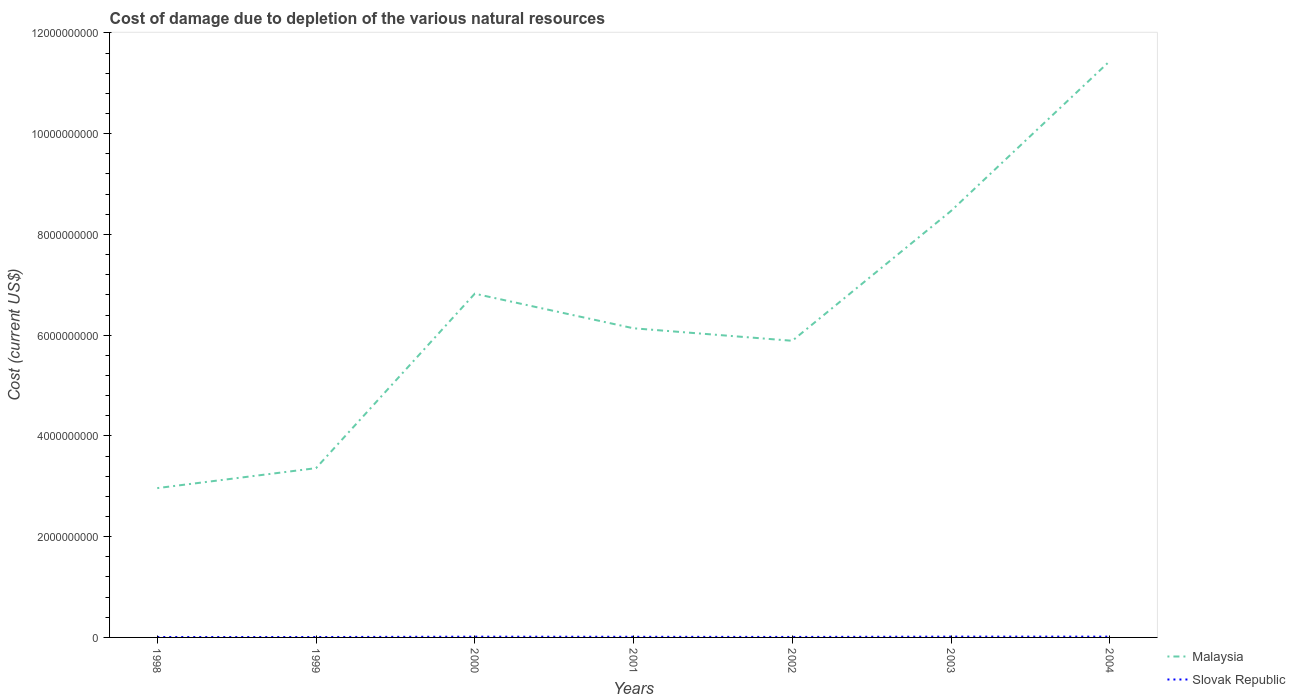How many different coloured lines are there?
Your answer should be very brief. 2. Is the number of lines equal to the number of legend labels?
Your response must be concise. Yes. Across all years, what is the maximum cost of damage caused due to the depletion of various natural resources in Malaysia?
Give a very brief answer. 2.96e+09. In which year was the cost of damage caused due to the depletion of various natural resources in Slovak Republic maximum?
Offer a terse response. 1998. What is the total cost of damage caused due to the depletion of various natural resources in Malaysia in the graph?
Make the answer very short. -2.78e+09. What is the difference between the highest and the second highest cost of damage caused due to the depletion of various natural resources in Malaysia?
Ensure brevity in your answer.  8.48e+09. What is the difference between the highest and the lowest cost of damage caused due to the depletion of various natural resources in Malaysia?
Provide a succinct answer. 3. How many years are there in the graph?
Offer a terse response. 7. Are the values on the major ticks of Y-axis written in scientific E-notation?
Provide a short and direct response. No. Does the graph contain any zero values?
Your answer should be compact. No. How are the legend labels stacked?
Give a very brief answer. Vertical. What is the title of the graph?
Make the answer very short. Cost of damage due to depletion of the various natural resources. Does "Timor-Leste" appear as one of the legend labels in the graph?
Provide a short and direct response. No. What is the label or title of the Y-axis?
Make the answer very short. Cost (current US$). What is the Cost (current US$) of Malaysia in 1998?
Your answer should be compact. 2.96e+09. What is the Cost (current US$) in Slovak Republic in 1998?
Your answer should be compact. 7.97e+06. What is the Cost (current US$) in Malaysia in 1999?
Ensure brevity in your answer.  3.36e+09. What is the Cost (current US$) in Slovak Republic in 1999?
Offer a very short reply. 8.02e+06. What is the Cost (current US$) of Malaysia in 2000?
Give a very brief answer. 6.82e+09. What is the Cost (current US$) of Slovak Republic in 2000?
Offer a very short reply. 1.49e+07. What is the Cost (current US$) in Malaysia in 2001?
Provide a succinct answer. 6.14e+09. What is the Cost (current US$) in Slovak Republic in 2001?
Your response must be concise. 1.26e+07. What is the Cost (current US$) in Malaysia in 2002?
Your answer should be very brief. 5.89e+09. What is the Cost (current US$) in Slovak Republic in 2002?
Your response must be concise. 9.72e+06. What is the Cost (current US$) of Malaysia in 2003?
Your response must be concise. 8.47e+09. What is the Cost (current US$) of Slovak Republic in 2003?
Your answer should be very brief. 1.58e+07. What is the Cost (current US$) of Malaysia in 2004?
Keep it short and to the point. 1.14e+1. What is the Cost (current US$) of Slovak Republic in 2004?
Give a very brief answer. 1.57e+07. Across all years, what is the maximum Cost (current US$) in Malaysia?
Give a very brief answer. 1.14e+1. Across all years, what is the maximum Cost (current US$) in Slovak Republic?
Give a very brief answer. 1.58e+07. Across all years, what is the minimum Cost (current US$) in Malaysia?
Provide a succinct answer. 2.96e+09. Across all years, what is the minimum Cost (current US$) of Slovak Republic?
Make the answer very short. 7.97e+06. What is the total Cost (current US$) of Malaysia in the graph?
Give a very brief answer. 4.51e+1. What is the total Cost (current US$) in Slovak Republic in the graph?
Give a very brief answer. 8.48e+07. What is the difference between the Cost (current US$) in Malaysia in 1998 and that in 1999?
Offer a terse response. -3.96e+08. What is the difference between the Cost (current US$) of Slovak Republic in 1998 and that in 1999?
Your answer should be very brief. -5.75e+04. What is the difference between the Cost (current US$) in Malaysia in 1998 and that in 2000?
Make the answer very short. -3.86e+09. What is the difference between the Cost (current US$) of Slovak Republic in 1998 and that in 2000?
Provide a short and direct response. -6.98e+06. What is the difference between the Cost (current US$) of Malaysia in 1998 and that in 2001?
Your answer should be very brief. -3.17e+09. What is the difference between the Cost (current US$) in Slovak Republic in 1998 and that in 2001?
Your response must be concise. -4.64e+06. What is the difference between the Cost (current US$) in Malaysia in 1998 and that in 2002?
Make the answer very short. -2.92e+09. What is the difference between the Cost (current US$) in Slovak Republic in 1998 and that in 2002?
Your answer should be compact. -1.76e+06. What is the difference between the Cost (current US$) in Malaysia in 1998 and that in 2003?
Provide a succinct answer. -5.50e+09. What is the difference between the Cost (current US$) of Slovak Republic in 1998 and that in 2003?
Keep it short and to the point. -7.83e+06. What is the difference between the Cost (current US$) in Malaysia in 1998 and that in 2004?
Keep it short and to the point. -8.48e+09. What is the difference between the Cost (current US$) of Slovak Republic in 1998 and that in 2004?
Ensure brevity in your answer.  -7.77e+06. What is the difference between the Cost (current US$) of Malaysia in 1999 and that in 2000?
Your answer should be compact. -3.46e+09. What is the difference between the Cost (current US$) in Slovak Republic in 1999 and that in 2000?
Provide a succinct answer. -6.92e+06. What is the difference between the Cost (current US$) in Malaysia in 1999 and that in 2001?
Provide a short and direct response. -2.78e+09. What is the difference between the Cost (current US$) of Slovak Republic in 1999 and that in 2001?
Offer a very short reply. -4.58e+06. What is the difference between the Cost (current US$) of Malaysia in 1999 and that in 2002?
Your response must be concise. -2.53e+09. What is the difference between the Cost (current US$) of Slovak Republic in 1999 and that in 2002?
Make the answer very short. -1.70e+06. What is the difference between the Cost (current US$) of Malaysia in 1999 and that in 2003?
Your response must be concise. -5.11e+09. What is the difference between the Cost (current US$) of Slovak Republic in 1999 and that in 2003?
Keep it short and to the point. -7.77e+06. What is the difference between the Cost (current US$) of Malaysia in 1999 and that in 2004?
Your answer should be very brief. -8.08e+09. What is the difference between the Cost (current US$) of Slovak Republic in 1999 and that in 2004?
Your response must be concise. -7.71e+06. What is the difference between the Cost (current US$) in Malaysia in 2000 and that in 2001?
Ensure brevity in your answer.  6.87e+08. What is the difference between the Cost (current US$) of Slovak Republic in 2000 and that in 2001?
Provide a succinct answer. 2.33e+06. What is the difference between the Cost (current US$) of Malaysia in 2000 and that in 2002?
Offer a terse response. 9.35e+08. What is the difference between the Cost (current US$) in Slovak Republic in 2000 and that in 2002?
Ensure brevity in your answer.  5.22e+06. What is the difference between the Cost (current US$) of Malaysia in 2000 and that in 2003?
Your answer should be compact. -1.64e+09. What is the difference between the Cost (current US$) of Slovak Republic in 2000 and that in 2003?
Your answer should be compact. -8.57e+05. What is the difference between the Cost (current US$) in Malaysia in 2000 and that in 2004?
Offer a terse response. -4.62e+09. What is the difference between the Cost (current US$) of Slovak Republic in 2000 and that in 2004?
Your response must be concise. -7.92e+05. What is the difference between the Cost (current US$) in Malaysia in 2001 and that in 2002?
Give a very brief answer. 2.48e+08. What is the difference between the Cost (current US$) in Slovak Republic in 2001 and that in 2002?
Offer a terse response. 2.89e+06. What is the difference between the Cost (current US$) of Malaysia in 2001 and that in 2003?
Provide a short and direct response. -2.33e+09. What is the difference between the Cost (current US$) of Slovak Republic in 2001 and that in 2003?
Your response must be concise. -3.19e+06. What is the difference between the Cost (current US$) of Malaysia in 2001 and that in 2004?
Your answer should be very brief. -5.31e+09. What is the difference between the Cost (current US$) of Slovak Republic in 2001 and that in 2004?
Your answer should be very brief. -3.13e+06. What is the difference between the Cost (current US$) of Malaysia in 2002 and that in 2003?
Your answer should be very brief. -2.58e+09. What is the difference between the Cost (current US$) of Slovak Republic in 2002 and that in 2003?
Your answer should be very brief. -6.08e+06. What is the difference between the Cost (current US$) of Malaysia in 2002 and that in 2004?
Your answer should be compact. -5.55e+09. What is the difference between the Cost (current US$) in Slovak Republic in 2002 and that in 2004?
Give a very brief answer. -6.01e+06. What is the difference between the Cost (current US$) of Malaysia in 2003 and that in 2004?
Provide a short and direct response. -2.98e+09. What is the difference between the Cost (current US$) of Slovak Republic in 2003 and that in 2004?
Offer a terse response. 6.52e+04. What is the difference between the Cost (current US$) of Malaysia in 1998 and the Cost (current US$) of Slovak Republic in 1999?
Offer a very short reply. 2.96e+09. What is the difference between the Cost (current US$) in Malaysia in 1998 and the Cost (current US$) in Slovak Republic in 2000?
Your answer should be very brief. 2.95e+09. What is the difference between the Cost (current US$) of Malaysia in 1998 and the Cost (current US$) of Slovak Republic in 2001?
Offer a terse response. 2.95e+09. What is the difference between the Cost (current US$) in Malaysia in 1998 and the Cost (current US$) in Slovak Republic in 2002?
Offer a very short reply. 2.95e+09. What is the difference between the Cost (current US$) in Malaysia in 1998 and the Cost (current US$) in Slovak Republic in 2003?
Keep it short and to the point. 2.95e+09. What is the difference between the Cost (current US$) in Malaysia in 1998 and the Cost (current US$) in Slovak Republic in 2004?
Offer a very short reply. 2.95e+09. What is the difference between the Cost (current US$) in Malaysia in 1999 and the Cost (current US$) in Slovak Republic in 2000?
Your answer should be very brief. 3.35e+09. What is the difference between the Cost (current US$) in Malaysia in 1999 and the Cost (current US$) in Slovak Republic in 2001?
Ensure brevity in your answer.  3.35e+09. What is the difference between the Cost (current US$) in Malaysia in 1999 and the Cost (current US$) in Slovak Republic in 2002?
Offer a very short reply. 3.35e+09. What is the difference between the Cost (current US$) in Malaysia in 1999 and the Cost (current US$) in Slovak Republic in 2003?
Offer a very short reply. 3.34e+09. What is the difference between the Cost (current US$) of Malaysia in 1999 and the Cost (current US$) of Slovak Republic in 2004?
Ensure brevity in your answer.  3.34e+09. What is the difference between the Cost (current US$) in Malaysia in 2000 and the Cost (current US$) in Slovak Republic in 2001?
Your response must be concise. 6.81e+09. What is the difference between the Cost (current US$) in Malaysia in 2000 and the Cost (current US$) in Slovak Republic in 2002?
Your response must be concise. 6.81e+09. What is the difference between the Cost (current US$) in Malaysia in 2000 and the Cost (current US$) in Slovak Republic in 2003?
Provide a short and direct response. 6.81e+09. What is the difference between the Cost (current US$) of Malaysia in 2000 and the Cost (current US$) of Slovak Republic in 2004?
Ensure brevity in your answer.  6.81e+09. What is the difference between the Cost (current US$) in Malaysia in 2001 and the Cost (current US$) in Slovak Republic in 2002?
Provide a short and direct response. 6.13e+09. What is the difference between the Cost (current US$) of Malaysia in 2001 and the Cost (current US$) of Slovak Republic in 2003?
Ensure brevity in your answer.  6.12e+09. What is the difference between the Cost (current US$) in Malaysia in 2001 and the Cost (current US$) in Slovak Republic in 2004?
Keep it short and to the point. 6.12e+09. What is the difference between the Cost (current US$) in Malaysia in 2002 and the Cost (current US$) in Slovak Republic in 2003?
Make the answer very short. 5.87e+09. What is the difference between the Cost (current US$) in Malaysia in 2002 and the Cost (current US$) in Slovak Republic in 2004?
Your response must be concise. 5.87e+09. What is the difference between the Cost (current US$) of Malaysia in 2003 and the Cost (current US$) of Slovak Republic in 2004?
Your response must be concise. 8.45e+09. What is the average Cost (current US$) of Malaysia per year?
Keep it short and to the point. 6.44e+09. What is the average Cost (current US$) of Slovak Republic per year?
Provide a short and direct response. 1.21e+07. In the year 1998, what is the difference between the Cost (current US$) in Malaysia and Cost (current US$) in Slovak Republic?
Keep it short and to the point. 2.96e+09. In the year 1999, what is the difference between the Cost (current US$) in Malaysia and Cost (current US$) in Slovak Republic?
Give a very brief answer. 3.35e+09. In the year 2000, what is the difference between the Cost (current US$) of Malaysia and Cost (current US$) of Slovak Republic?
Offer a very short reply. 6.81e+09. In the year 2001, what is the difference between the Cost (current US$) of Malaysia and Cost (current US$) of Slovak Republic?
Provide a short and direct response. 6.12e+09. In the year 2002, what is the difference between the Cost (current US$) in Malaysia and Cost (current US$) in Slovak Republic?
Provide a short and direct response. 5.88e+09. In the year 2003, what is the difference between the Cost (current US$) in Malaysia and Cost (current US$) in Slovak Republic?
Offer a very short reply. 8.45e+09. In the year 2004, what is the difference between the Cost (current US$) in Malaysia and Cost (current US$) in Slovak Republic?
Provide a short and direct response. 1.14e+1. What is the ratio of the Cost (current US$) of Malaysia in 1998 to that in 1999?
Offer a very short reply. 0.88. What is the ratio of the Cost (current US$) of Slovak Republic in 1998 to that in 1999?
Provide a short and direct response. 0.99. What is the ratio of the Cost (current US$) in Malaysia in 1998 to that in 2000?
Your response must be concise. 0.43. What is the ratio of the Cost (current US$) of Slovak Republic in 1998 to that in 2000?
Provide a succinct answer. 0.53. What is the ratio of the Cost (current US$) of Malaysia in 1998 to that in 2001?
Your answer should be very brief. 0.48. What is the ratio of the Cost (current US$) of Slovak Republic in 1998 to that in 2001?
Offer a very short reply. 0.63. What is the ratio of the Cost (current US$) in Malaysia in 1998 to that in 2002?
Provide a short and direct response. 0.5. What is the ratio of the Cost (current US$) of Slovak Republic in 1998 to that in 2002?
Your answer should be very brief. 0.82. What is the ratio of the Cost (current US$) in Malaysia in 1998 to that in 2003?
Offer a terse response. 0.35. What is the ratio of the Cost (current US$) of Slovak Republic in 1998 to that in 2003?
Ensure brevity in your answer.  0.5. What is the ratio of the Cost (current US$) of Malaysia in 1998 to that in 2004?
Keep it short and to the point. 0.26. What is the ratio of the Cost (current US$) in Slovak Republic in 1998 to that in 2004?
Your answer should be compact. 0.51. What is the ratio of the Cost (current US$) of Malaysia in 1999 to that in 2000?
Give a very brief answer. 0.49. What is the ratio of the Cost (current US$) in Slovak Republic in 1999 to that in 2000?
Offer a very short reply. 0.54. What is the ratio of the Cost (current US$) in Malaysia in 1999 to that in 2001?
Your answer should be very brief. 0.55. What is the ratio of the Cost (current US$) of Slovak Republic in 1999 to that in 2001?
Your answer should be compact. 0.64. What is the ratio of the Cost (current US$) of Malaysia in 1999 to that in 2002?
Ensure brevity in your answer.  0.57. What is the ratio of the Cost (current US$) of Slovak Republic in 1999 to that in 2002?
Offer a terse response. 0.83. What is the ratio of the Cost (current US$) in Malaysia in 1999 to that in 2003?
Your response must be concise. 0.4. What is the ratio of the Cost (current US$) in Slovak Republic in 1999 to that in 2003?
Provide a succinct answer. 0.51. What is the ratio of the Cost (current US$) in Malaysia in 1999 to that in 2004?
Give a very brief answer. 0.29. What is the ratio of the Cost (current US$) in Slovak Republic in 1999 to that in 2004?
Give a very brief answer. 0.51. What is the ratio of the Cost (current US$) in Malaysia in 2000 to that in 2001?
Your answer should be compact. 1.11. What is the ratio of the Cost (current US$) in Slovak Republic in 2000 to that in 2001?
Your answer should be very brief. 1.19. What is the ratio of the Cost (current US$) of Malaysia in 2000 to that in 2002?
Your answer should be compact. 1.16. What is the ratio of the Cost (current US$) in Slovak Republic in 2000 to that in 2002?
Make the answer very short. 1.54. What is the ratio of the Cost (current US$) of Malaysia in 2000 to that in 2003?
Offer a terse response. 0.81. What is the ratio of the Cost (current US$) of Slovak Republic in 2000 to that in 2003?
Provide a succinct answer. 0.95. What is the ratio of the Cost (current US$) of Malaysia in 2000 to that in 2004?
Provide a succinct answer. 0.6. What is the ratio of the Cost (current US$) in Slovak Republic in 2000 to that in 2004?
Your answer should be compact. 0.95. What is the ratio of the Cost (current US$) of Malaysia in 2001 to that in 2002?
Offer a very short reply. 1.04. What is the ratio of the Cost (current US$) in Slovak Republic in 2001 to that in 2002?
Make the answer very short. 1.3. What is the ratio of the Cost (current US$) in Malaysia in 2001 to that in 2003?
Your response must be concise. 0.72. What is the ratio of the Cost (current US$) in Slovak Republic in 2001 to that in 2003?
Make the answer very short. 0.8. What is the ratio of the Cost (current US$) in Malaysia in 2001 to that in 2004?
Provide a short and direct response. 0.54. What is the ratio of the Cost (current US$) in Slovak Republic in 2001 to that in 2004?
Make the answer very short. 0.8. What is the ratio of the Cost (current US$) in Malaysia in 2002 to that in 2003?
Provide a short and direct response. 0.7. What is the ratio of the Cost (current US$) of Slovak Republic in 2002 to that in 2003?
Give a very brief answer. 0.62. What is the ratio of the Cost (current US$) in Malaysia in 2002 to that in 2004?
Ensure brevity in your answer.  0.51. What is the ratio of the Cost (current US$) of Slovak Republic in 2002 to that in 2004?
Ensure brevity in your answer.  0.62. What is the ratio of the Cost (current US$) in Malaysia in 2003 to that in 2004?
Offer a very short reply. 0.74. What is the difference between the highest and the second highest Cost (current US$) of Malaysia?
Make the answer very short. 2.98e+09. What is the difference between the highest and the second highest Cost (current US$) in Slovak Republic?
Offer a very short reply. 6.52e+04. What is the difference between the highest and the lowest Cost (current US$) in Malaysia?
Offer a terse response. 8.48e+09. What is the difference between the highest and the lowest Cost (current US$) in Slovak Republic?
Your answer should be compact. 7.83e+06. 